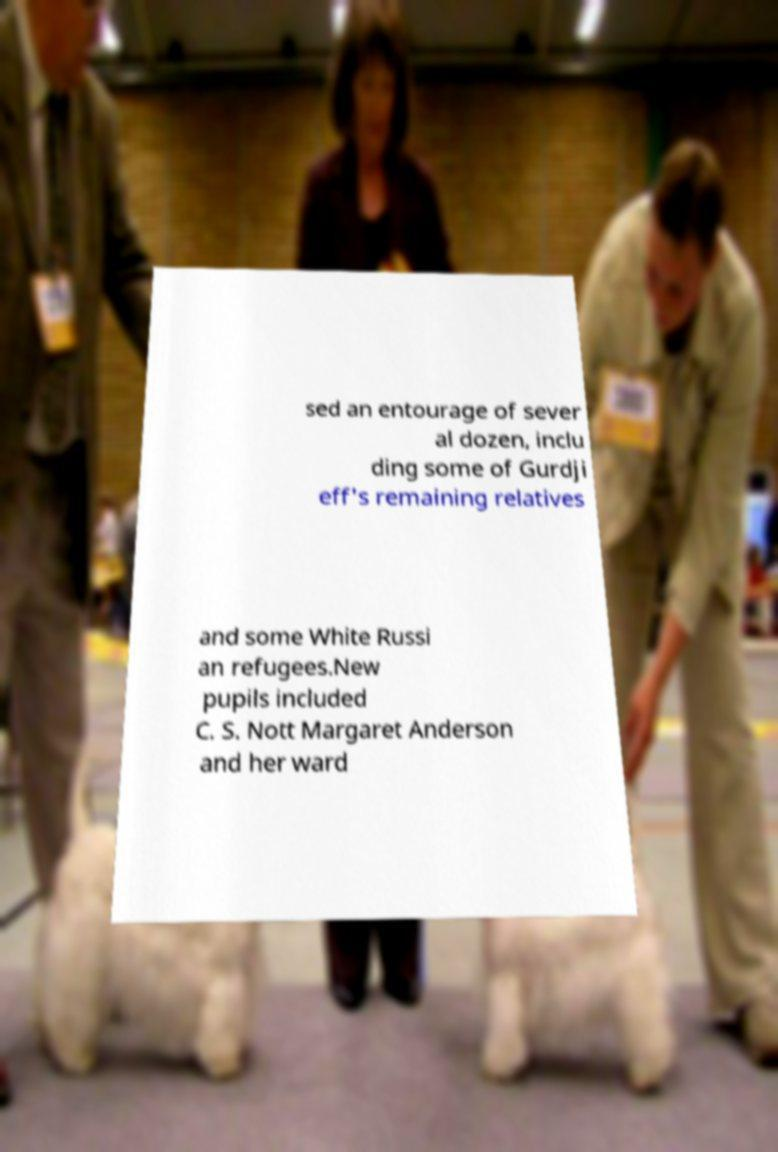What messages or text are displayed in this image? I need them in a readable, typed format. sed an entourage of sever al dozen, inclu ding some of Gurdji eff's remaining relatives and some White Russi an refugees.New pupils included C. S. Nott Margaret Anderson and her ward 